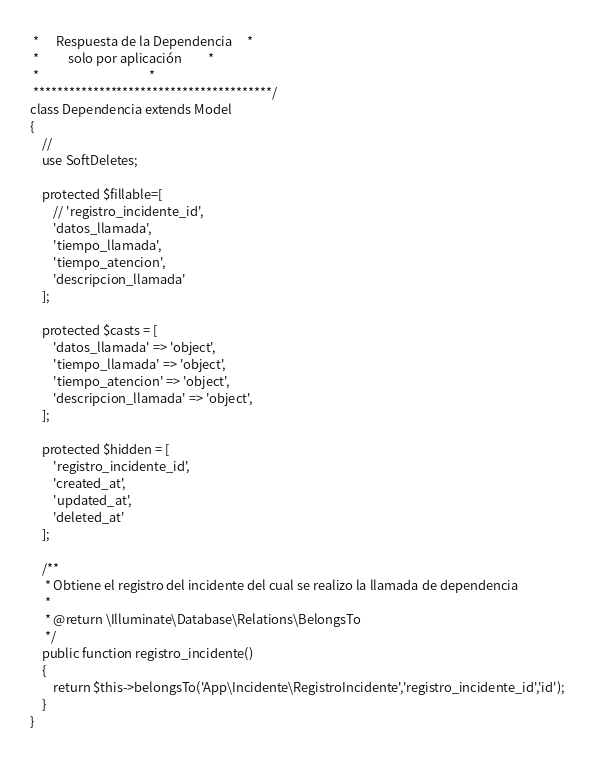<code> <loc_0><loc_0><loc_500><loc_500><_PHP_> *      Respuesta de la Dependencia     *
 *          solo por aplicación         *
 *                                      *
 ****************************************/
class Dependencia extends Model
{
    //
    use SoftDeletes;

    protected $fillable=[
    	// 'registro_incidente_id',
    	'datos_llamada',
    	'tiempo_llamada',
    	'tiempo_atencion',
    	'descripcion_llamada'
    ];

    protected $casts = [
    	'datos_llamada' => 'object',
    	'tiempo_llamada' => 'object',
    	'tiempo_atencion' => 'object',
    	'descripcion_llamada' => 'object',
    ];

    protected $hidden = [
        'registro_incidente_id',
        'created_at',
        'updated_at',
        'deleted_at'
    ];

    /**
     * Obtiene el registro del incidente del cual se realizo la llamada de dependencia
     *
     * @return \Illuminate\Database\Relations\BelongsTo
     */
    public function registro_incidente()
    {
    	return $this->belongsTo('App\Incidente\RegistroIncidente','registro_incidente_id','id');
    }
}
</code> 